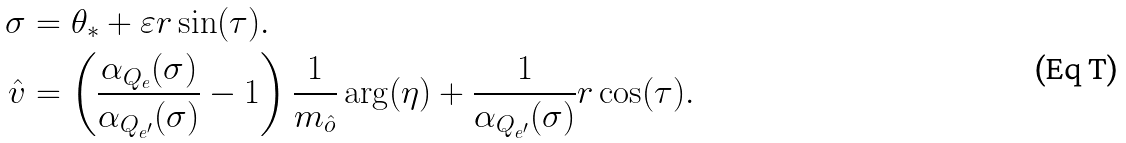Convert formula to latex. <formula><loc_0><loc_0><loc_500><loc_500>\sigma & = \theta _ { * } + \varepsilon r \sin ( \tau ) . \\ \hat { v } & = \left ( \frac { \alpha _ { Q _ { e } } ( \sigma ) } { \alpha _ { Q _ { e ^ { \prime } } } ( \sigma ) } - 1 \right ) \frac { 1 } { m _ { \hat { o } } } \arg ( \eta ) + \frac { 1 } { \alpha _ { Q _ { e ^ { \prime } } } ( \sigma ) } r \cos ( \tau ) .</formula> 